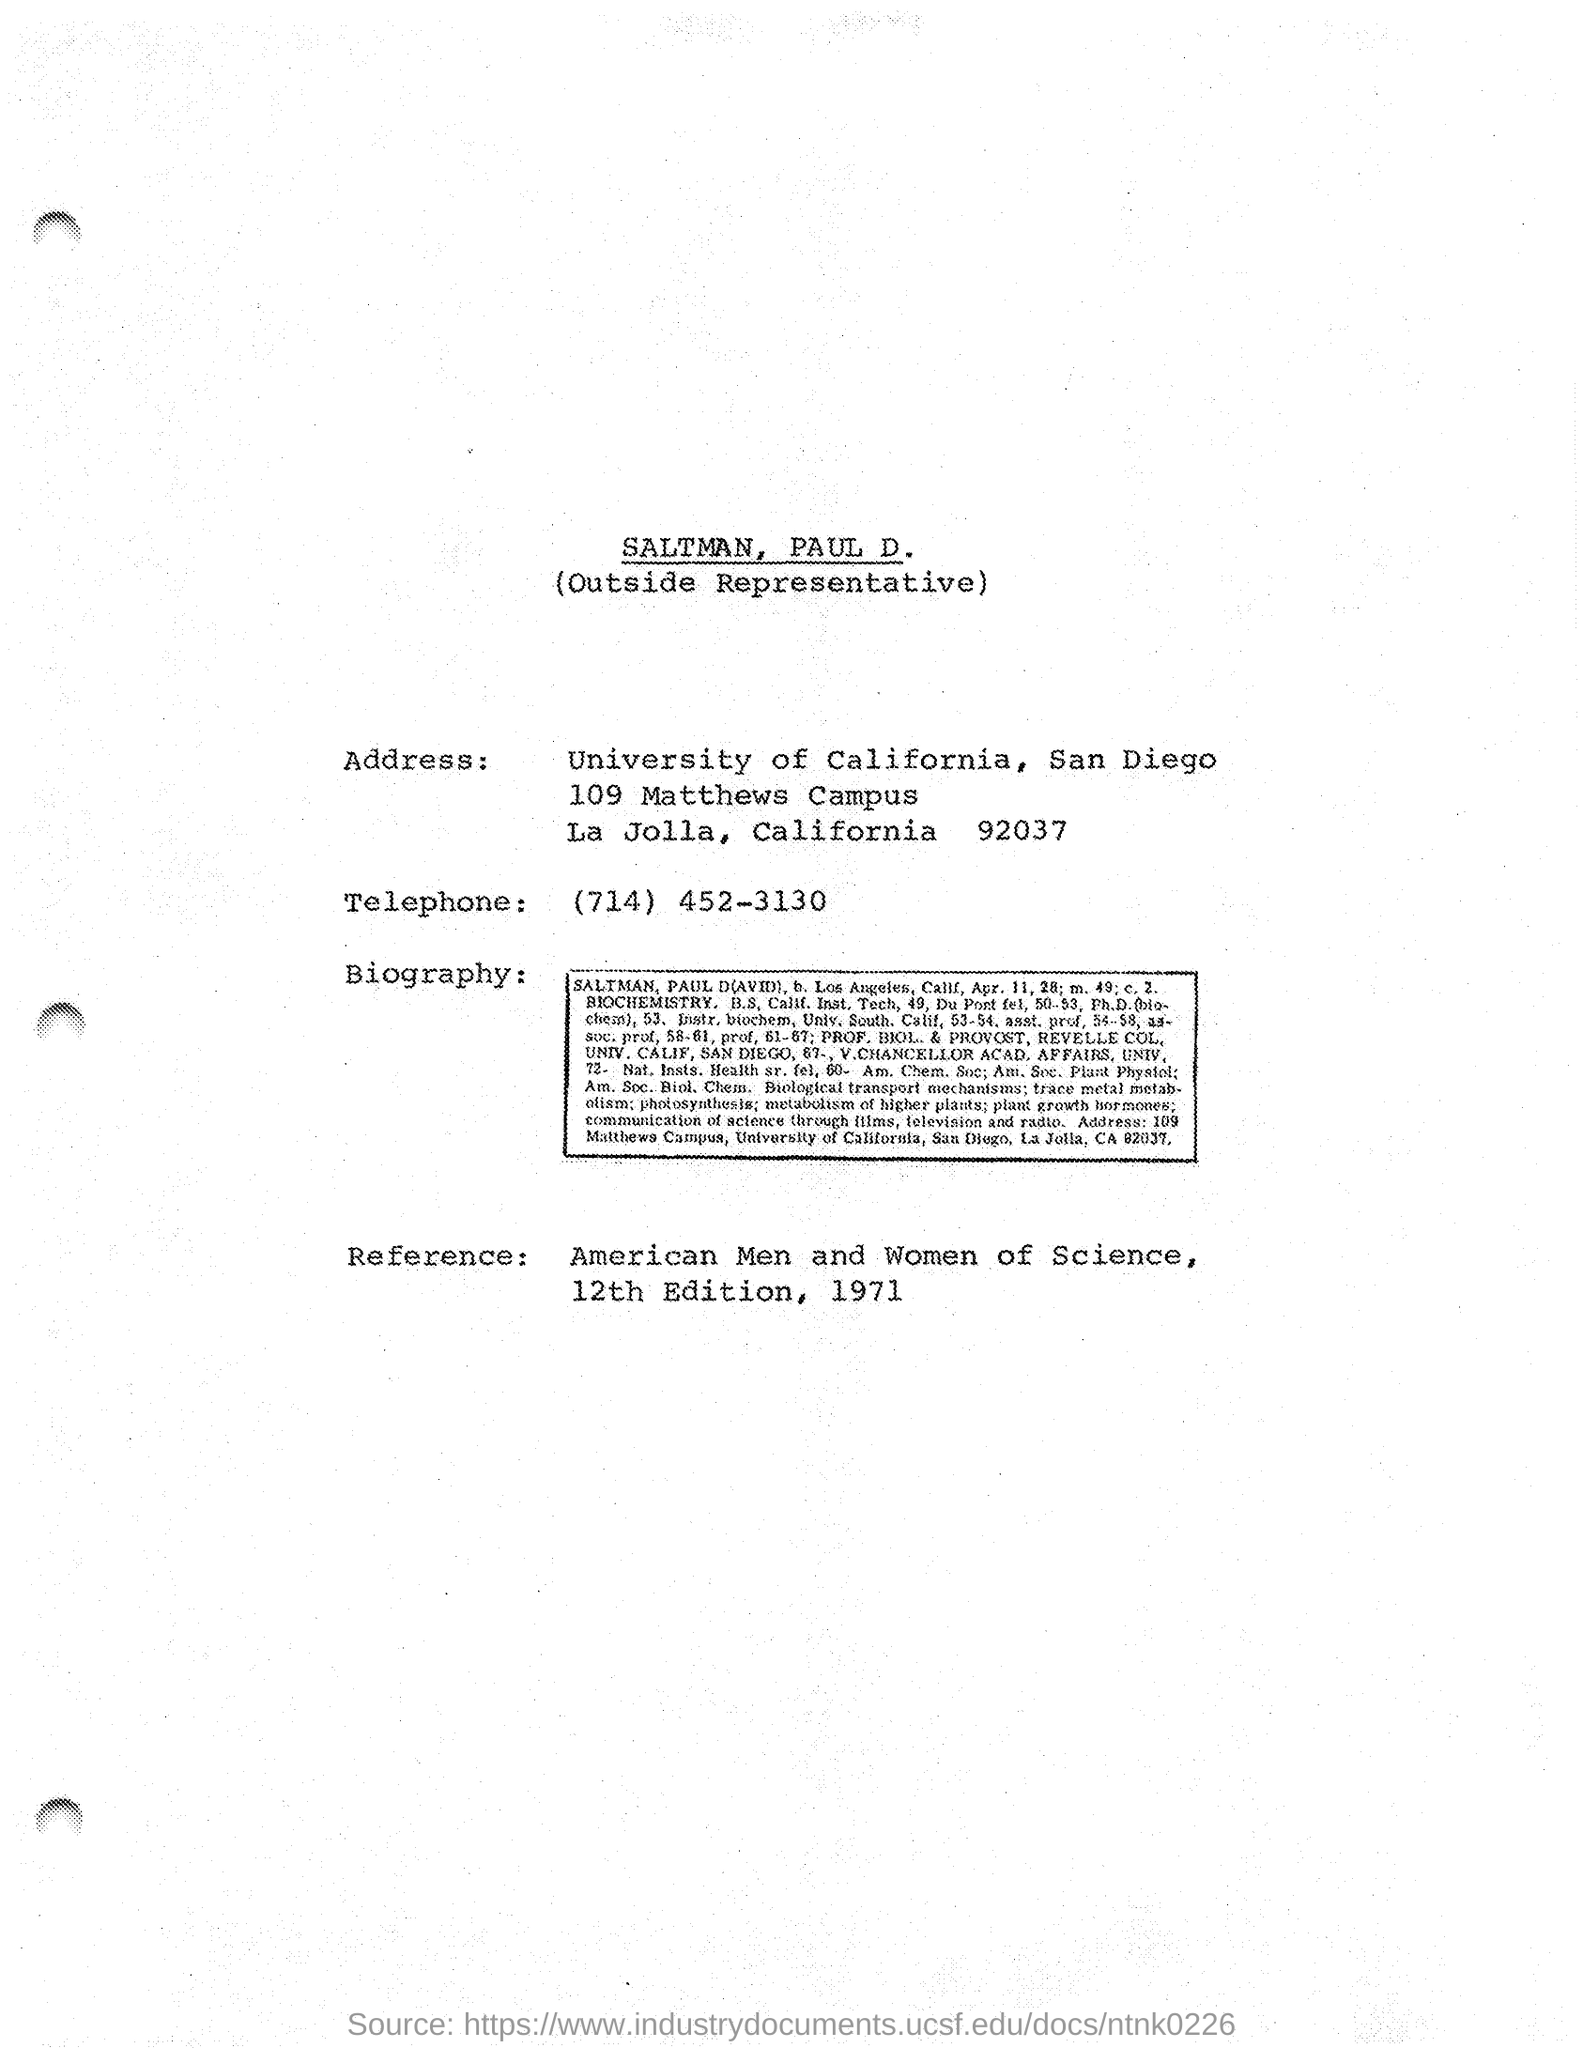Indicate a few pertinent items in this graphic. The telephone is a device that is used to transmit and receive voice communications over a distance through the use of electronic signals. The telephone number "(714) 452-3130" is a unique identifier assigned to a specific telephone line for the purpose of making and receiving calls. Who is the Outside Representative? Paul D. Saltman. 